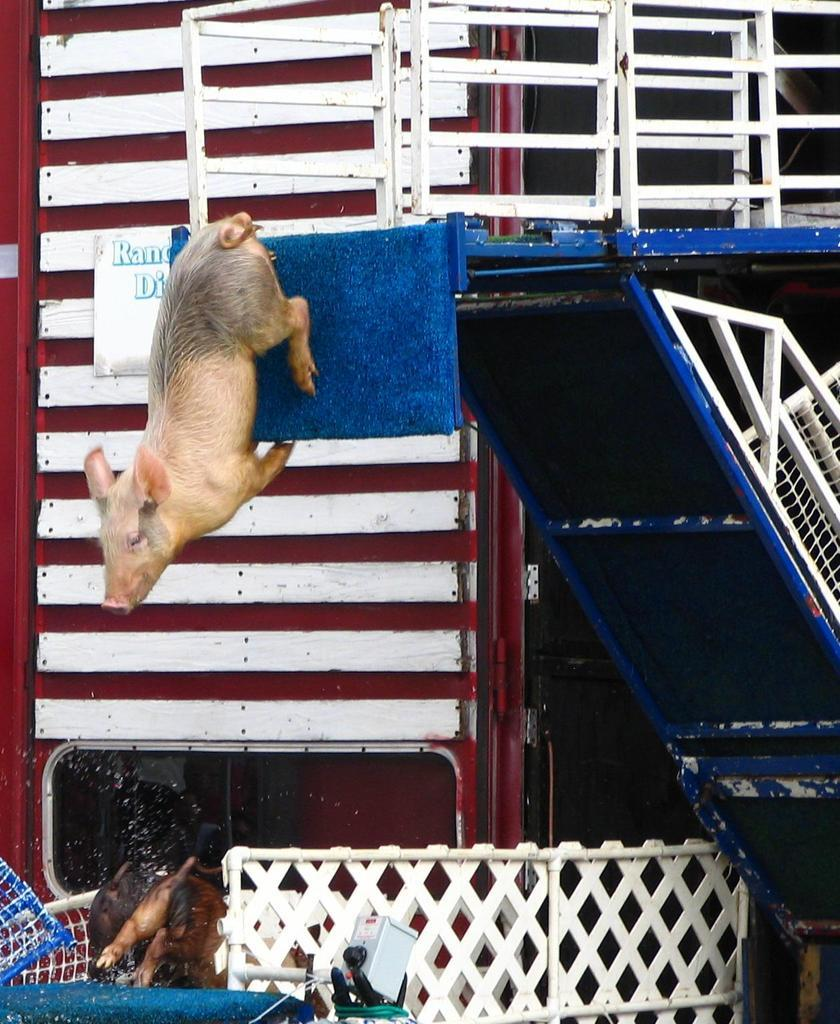What type of animal is in the image? There is a pig in the image. What can be seen near the pig? There are railings in the image. What is written or displayed on the wall in the image? There is a board on the wall with text in the image. What is the animal in the basket? There is an animal in a basket in the image, but the specific type of animal is not mentioned in the facts. What structure is present in the image? There is a stand in the image. What type of cough medicine is on the stand in the image? There is no cough medicine or any reference to medicine in the image. 